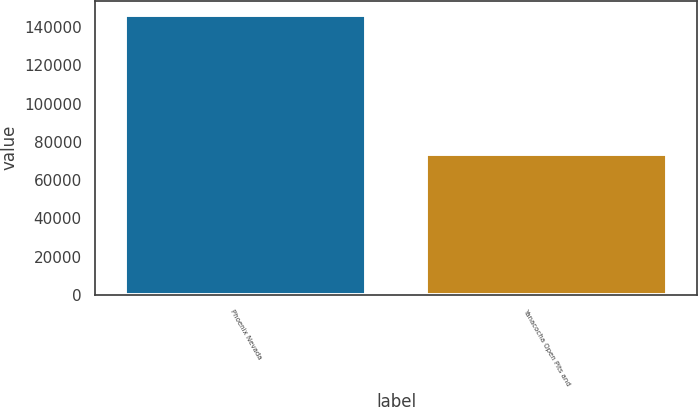Convert chart to OTSL. <chart><loc_0><loc_0><loc_500><loc_500><bar_chart><fcel>Phoenix Nevada<fcel>Yanacocha Open Pits and<nl><fcel>146400<fcel>73400<nl></chart> 